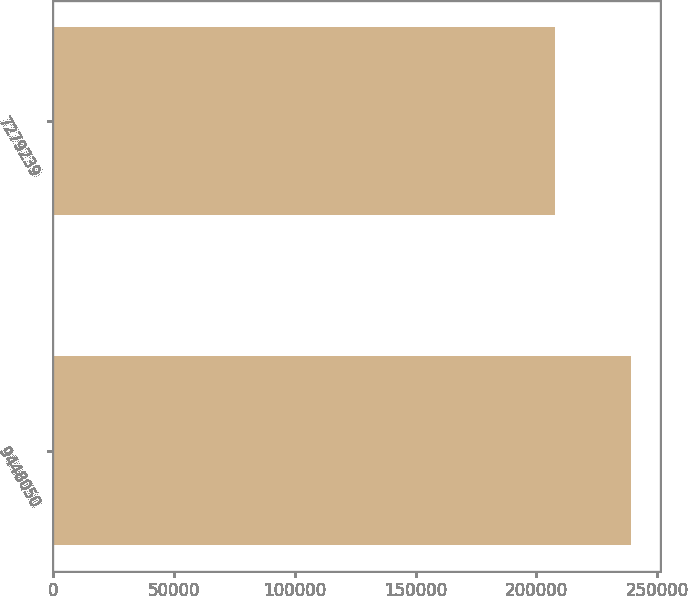Convert chart. <chart><loc_0><loc_0><loc_500><loc_500><bar_chart><fcel>9448050<fcel>7279239<nl><fcel>239342<fcel>207939<nl></chart> 